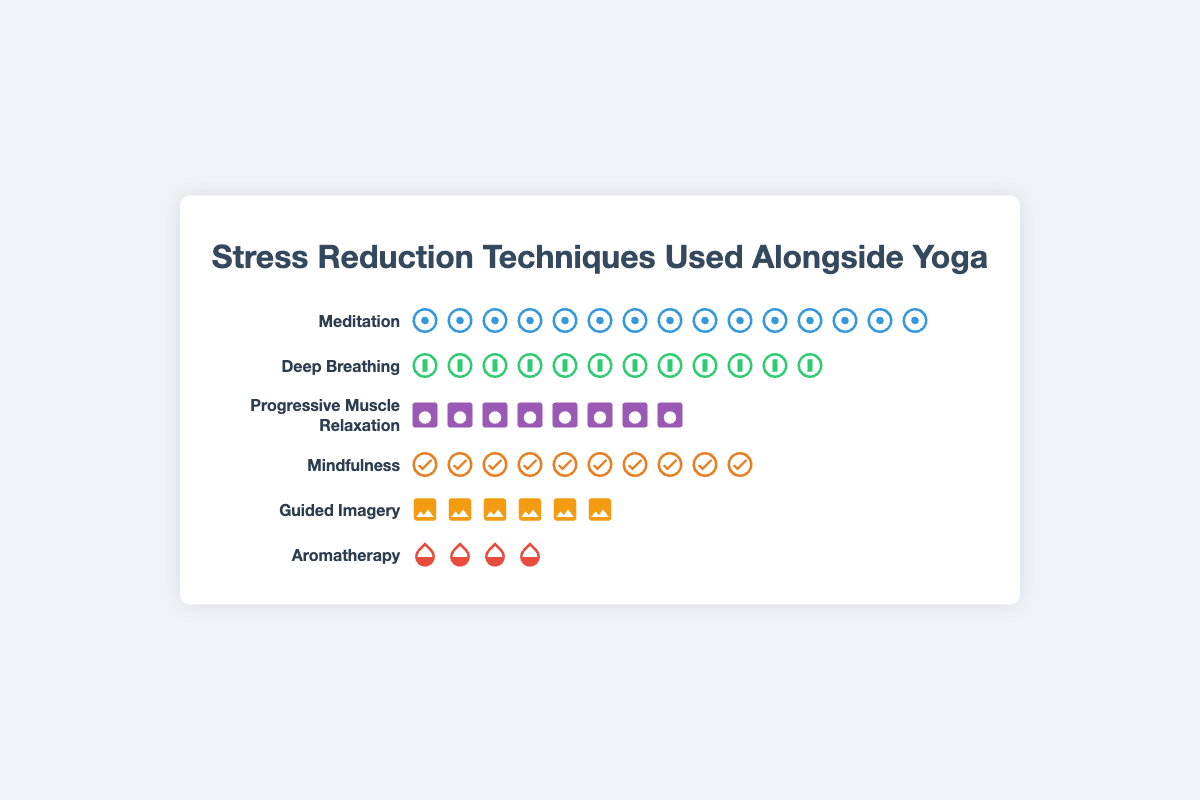Which stress reduction technique is used the most alongside yoga? The technique with the highest number of icons in the isotype plot is Meditation with 15 icons.
Answer: Meditation How many techniques are used alongside yoga in total? Count each technique listed in the isotype plot. There are six techniques: Meditation, Deep Breathing, Progressive Muscle Relaxation, Mindfulness, Guided Imagery, and Aromatherapy.
Answer: 6 Which technique appears more frequently: Deep Breathing or Progressive Muscle Relaxation? Compare the number of icons for both techniques. Deep Breathing has 12 icons while Progressive Muscle Relaxation has 8.
Answer: Deep Breathing What is the total count of all techniques used alongside yoga? Sum the counts of all the techniques: 15 (Meditation) + 12 (Deep Breathing) + 8 (Progressive Muscle Relaxation) + 10 (Mindfulness) + 6 (Guided Imagery) + 4 (Aromatherapy) = 55.
Answer: 55 Which technique has the fewest representations, and how many times is it mentioned? Identify the technique with the fewest icons. Aromatherapy has 4 icons, which is the smallest number.
Answer: Aromatherapy, 4 How many more times is Meditation used compared to Guided Imagery? Subtract the count of Guided Imagery from Meditation: 15 (Meditation) - 6 (Guided Imagery) = 9.
Answer: 9 Are there any techniques used exactly twice as much as Aromatherapy? Check the counts of other techniques and compare to twice the count of Aromatherapy (2 * 4 = 8). Progressive Muscle Relaxation matches this with a count of 8.
Answer: Progressive Muscle Relaxation What is the average number of representations per technique? Calculate the mean of the counts: (15 + 12 + 8 + 10 + 6 + 4) / 6 = 55 / 6 ≈ 9.17.
Answer: 9.17 How much more frequently is Mindfulness used compared to Aromatherapy in the study? Subtract the count of Aromatherapy from Mindfulness: 10 (Mindfulness) - 4 (Aromatherapy) = 6.
Answer: 6 What is the percentage representation of Deep Breathing among all techniques? Calculate the percentage: (12 / 55) * 100 ≈ 21.82%.
Answer: 21.82% 